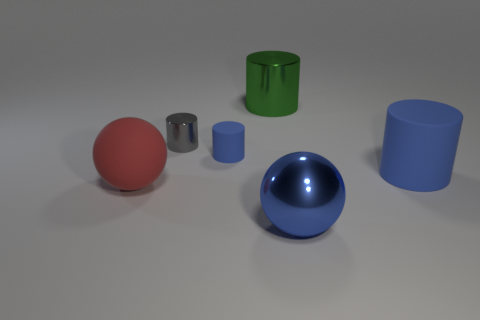Add 1 small gray metallic objects. How many objects exist? 7 Subtract all spheres. How many objects are left? 4 Add 3 green metal cylinders. How many green metal cylinders are left? 4 Add 5 big metal things. How many big metal things exist? 7 Subtract 0 cyan spheres. How many objects are left? 6 Subtract all blue metal balls. Subtract all big blue shiny balls. How many objects are left? 4 